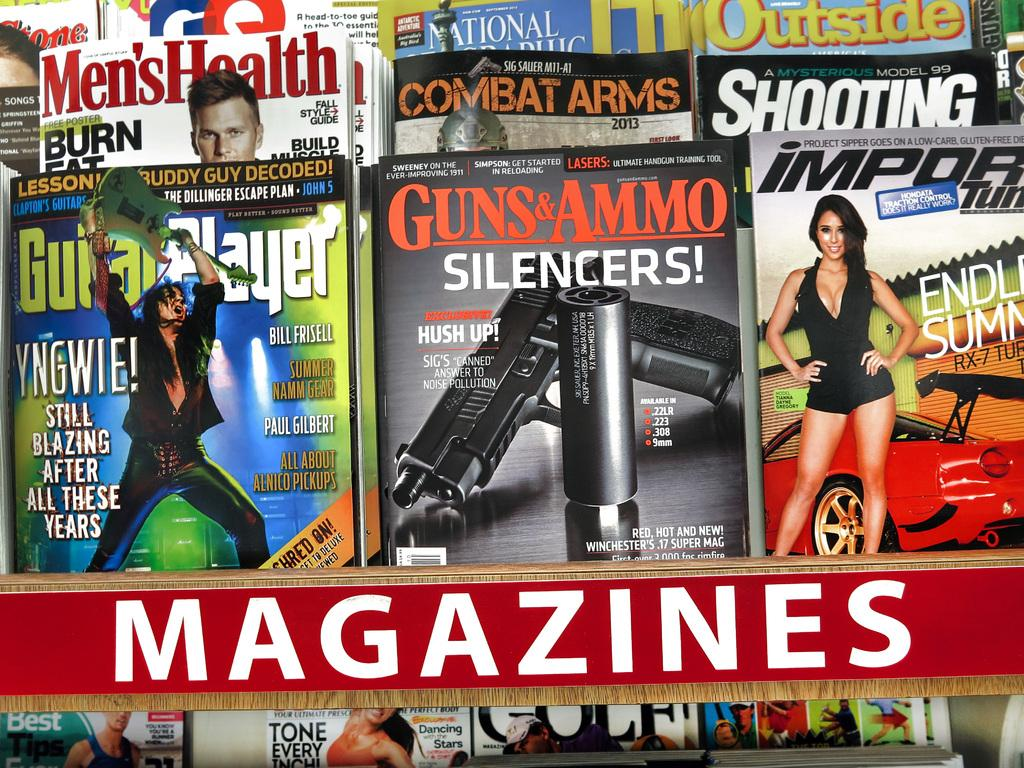What type of items can be seen in the image? There are books in the image. What is depicted on the covers of the books? Photos of people, a gun, and other objects are visible on the covers of the books. Is there any text present in the image? Yes, there is writing on the image. How does the image depict the distribution of wealth among the people in the photos? The image does not depict the distribution of wealth among the people in the photos; it only shows photos of people on the covers of the books. 